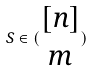<formula> <loc_0><loc_0><loc_500><loc_500>S \in ( \begin{matrix} [ n ] \\ m \end{matrix} )</formula> 